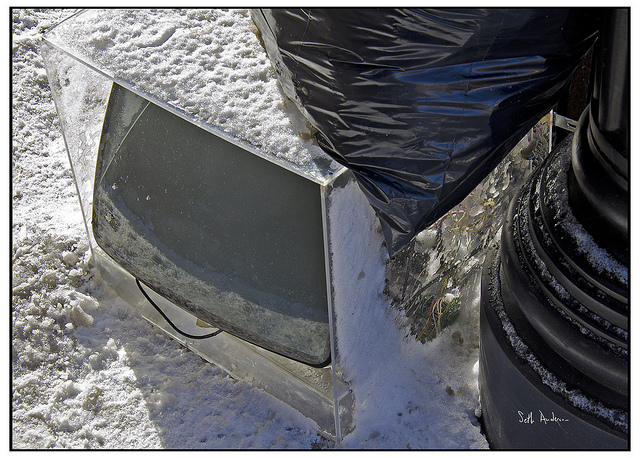<image>What is in the black bag? I don't know what is in the black bag. It could be trash, garbage, or sand. What is in the black bag? I don't know what is in the black bag. It can be trash, garbage, or something else. 